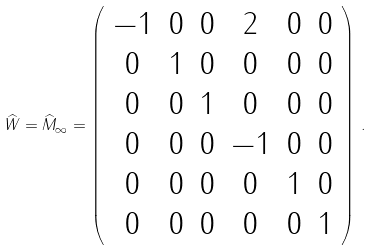<formula> <loc_0><loc_0><loc_500><loc_500>\widehat { W } = { \widehat { M } } _ { \infty } = \left ( \begin{array} { c c c c c c } { - 1 } & { 0 } & { 0 } & { 2 } & { 0 } & { 0 } \\ { 0 } & { 1 } & { 0 } & { 0 } & { 0 } & { 0 } \\ { 0 } & { 0 } & { 1 } & { 0 } & { 0 } & { 0 } \\ { 0 } & { 0 } & { 0 } & { - 1 } & { 0 } & { 0 } \\ { 0 } & { 0 } & { 0 } & { 0 } & { 1 } & { 0 } \\ { 0 } & { 0 } & { 0 } & { 0 } & { 0 } & { 1 } \end{array} \right ) \, .</formula> 